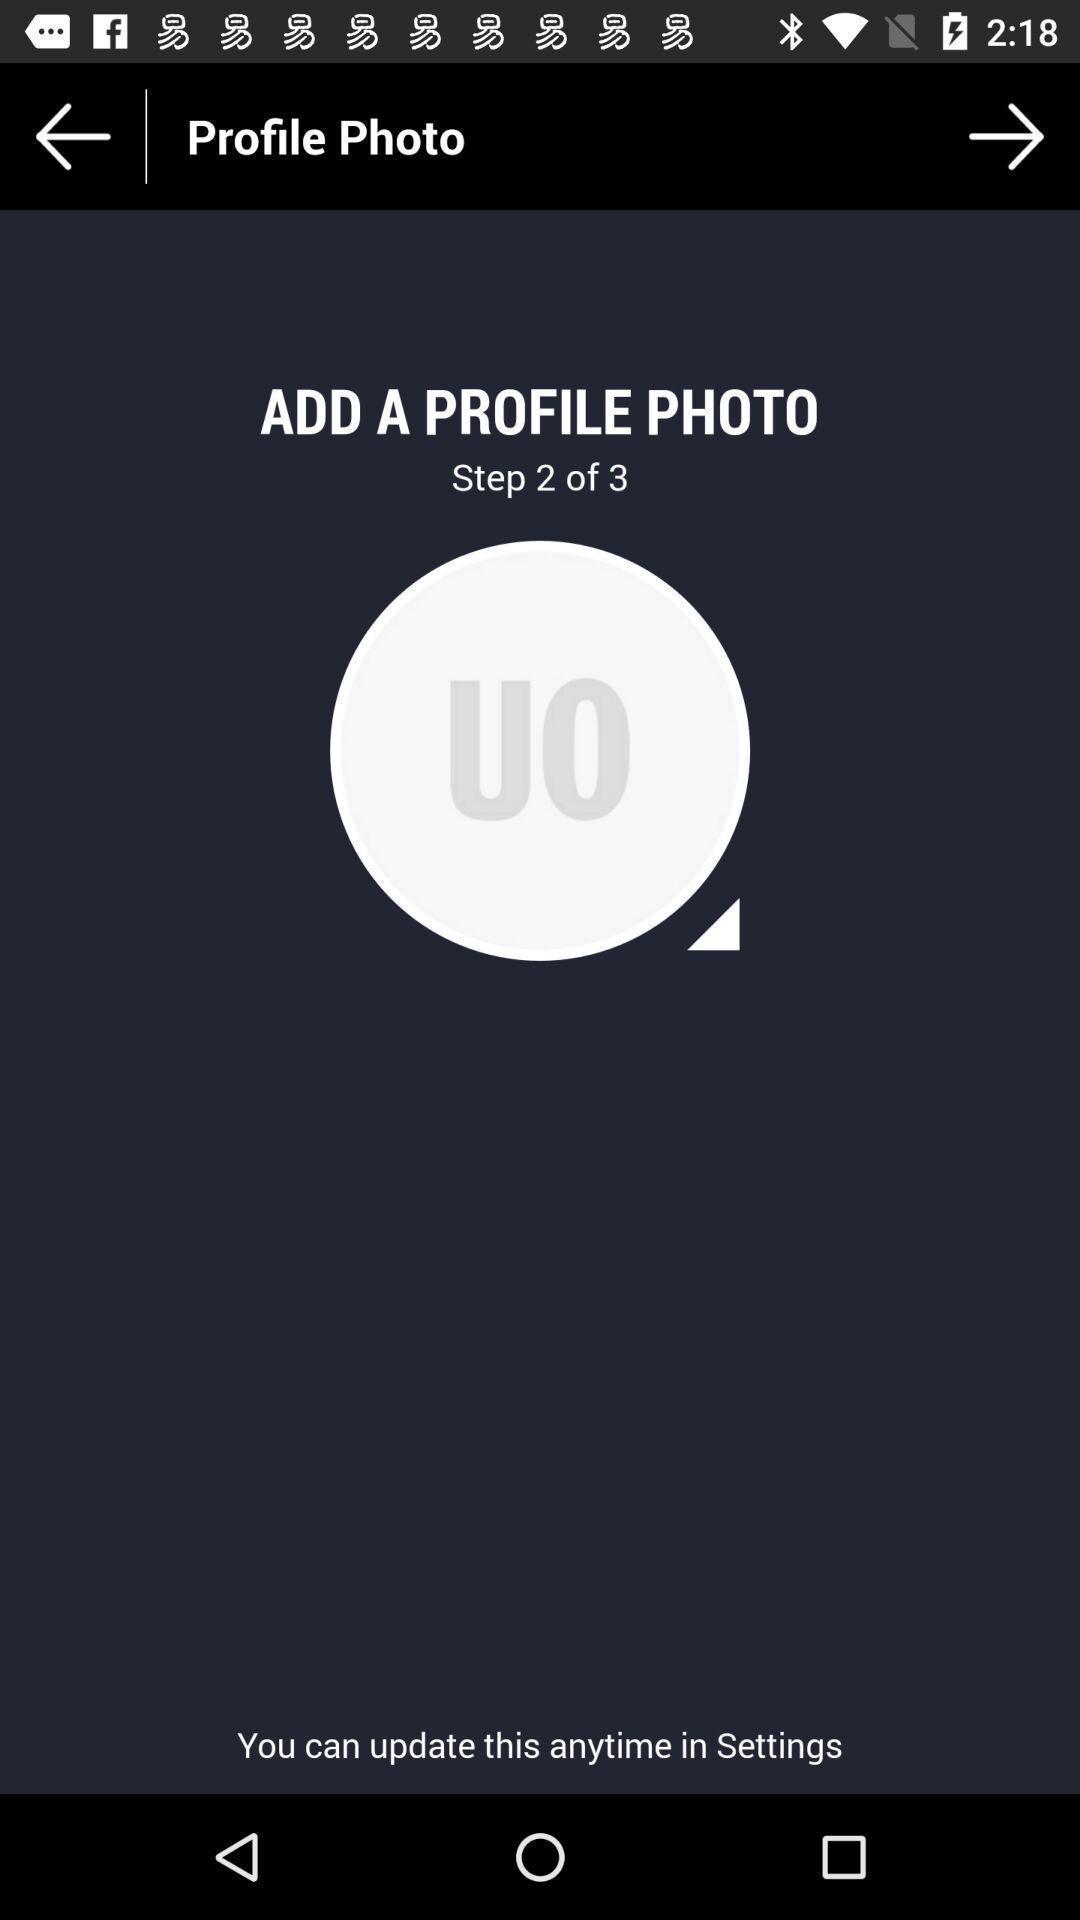Describe the visual elements of this screenshot. Page displaying to add profile photo in app. 